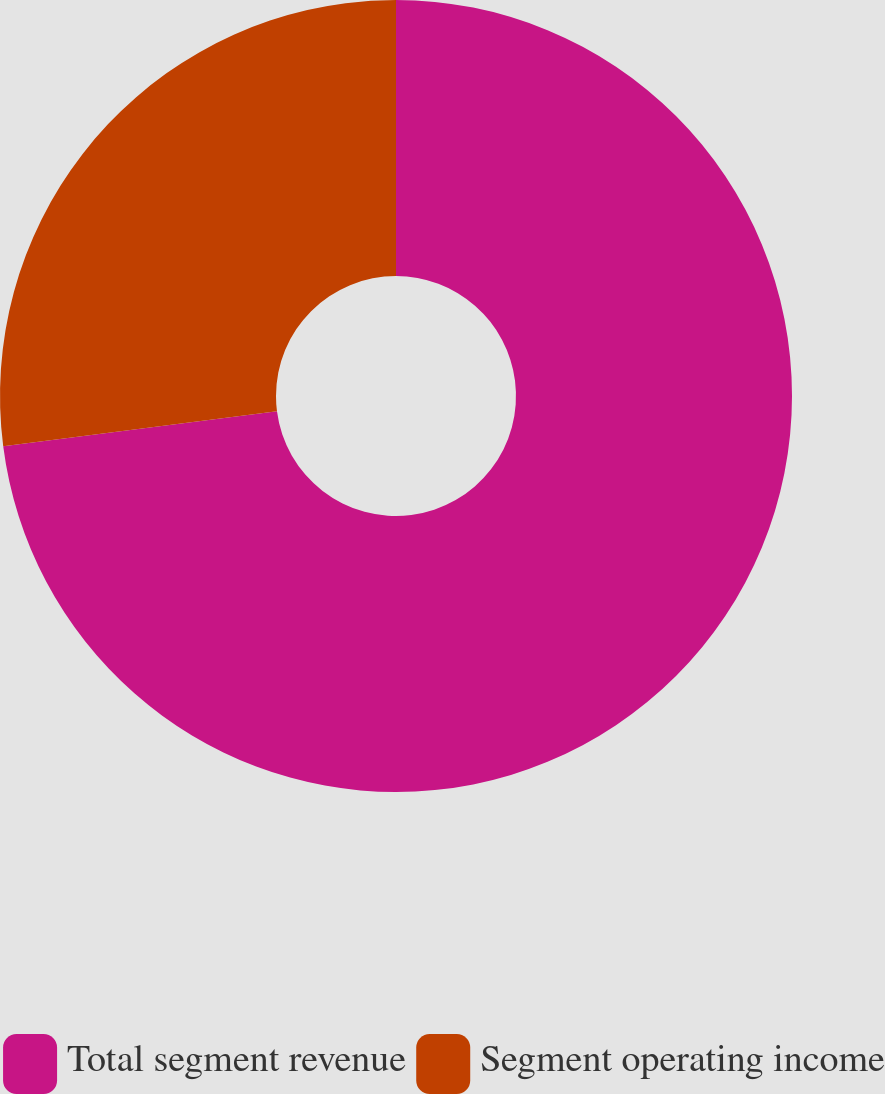<chart> <loc_0><loc_0><loc_500><loc_500><pie_chart><fcel>Total segment revenue<fcel>Segment operating income<nl><fcel>72.97%<fcel>27.03%<nl></chart> 